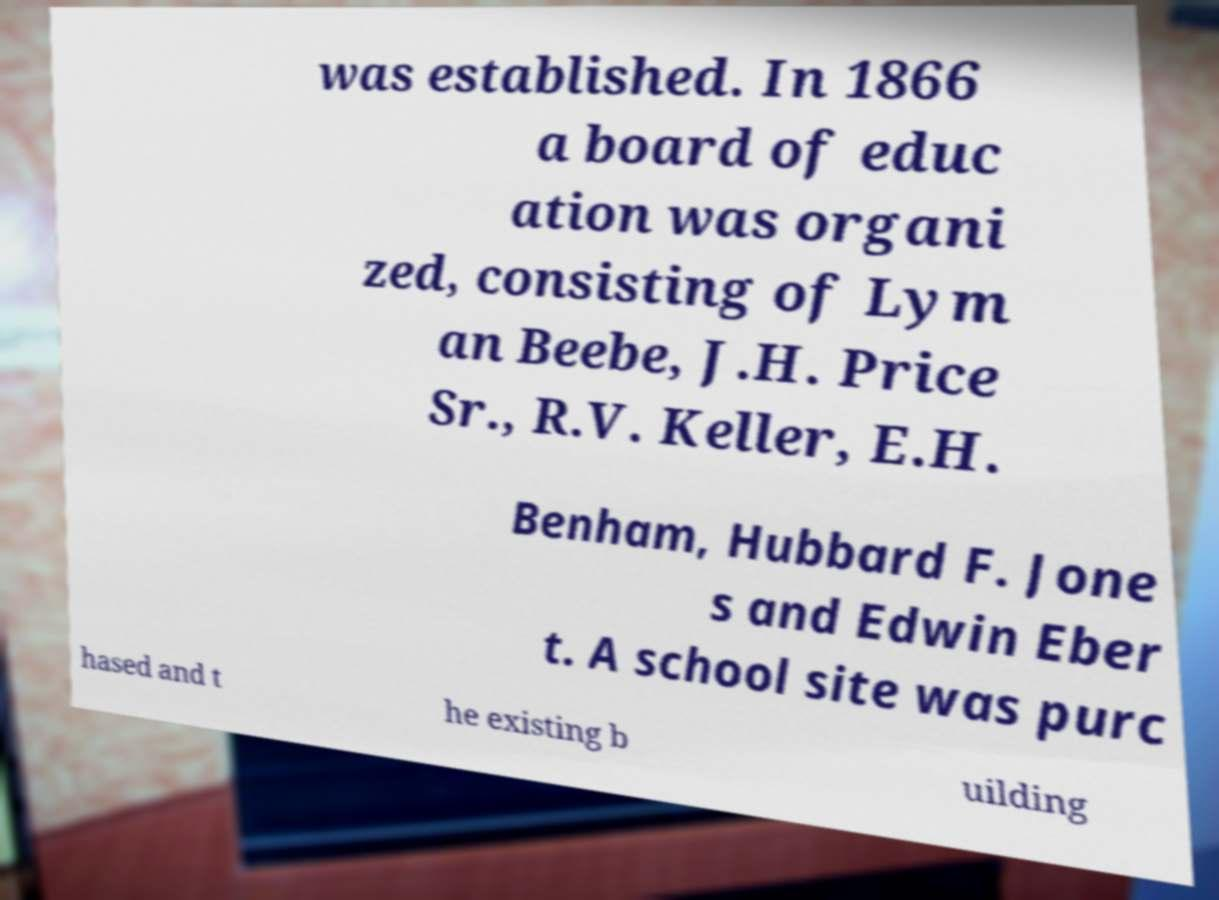I need the written content from this picture converted into text. Can you do that? was established. In 1866 a board of educ ation was organi zed, consisting of Lym an Beebe, J.H. Price Sr., R.V. Keller, E.H. Benham, Hubbard F. Jone s and Edwin Eber t. A school site was purc hased and t he existing b uilding 